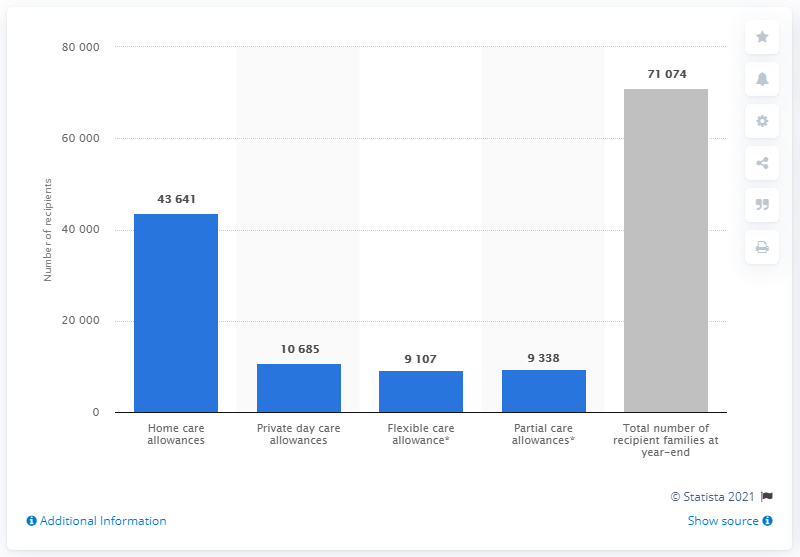Highlight a few significant elements in this photo. The value of the highest bar is 71074. In 2019, there were 4,364 home care allowance recipients in Finland. In 2019, there were 10,685 private day care recipients in Finland. The total of the blue bars is 7,277.1. As of 2019, a total of 71,074 families in Finland received child care allowances. 